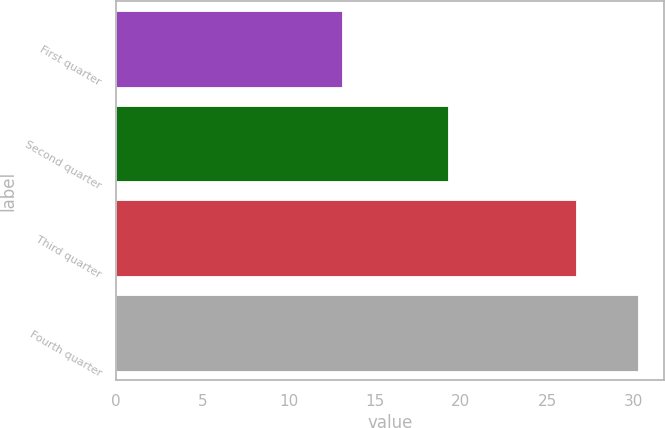Convert chart. <chart><loc_0><loc_0><loc_500><loc_500><bar_chart><fcel>First quarter<fcel>Second quarter<fcel>Third quarter<fcel>Fourth quarter<nl><fcel>13.12<fcel>19.27<fcel>26.65<fcel>30.25<nl></chart> 